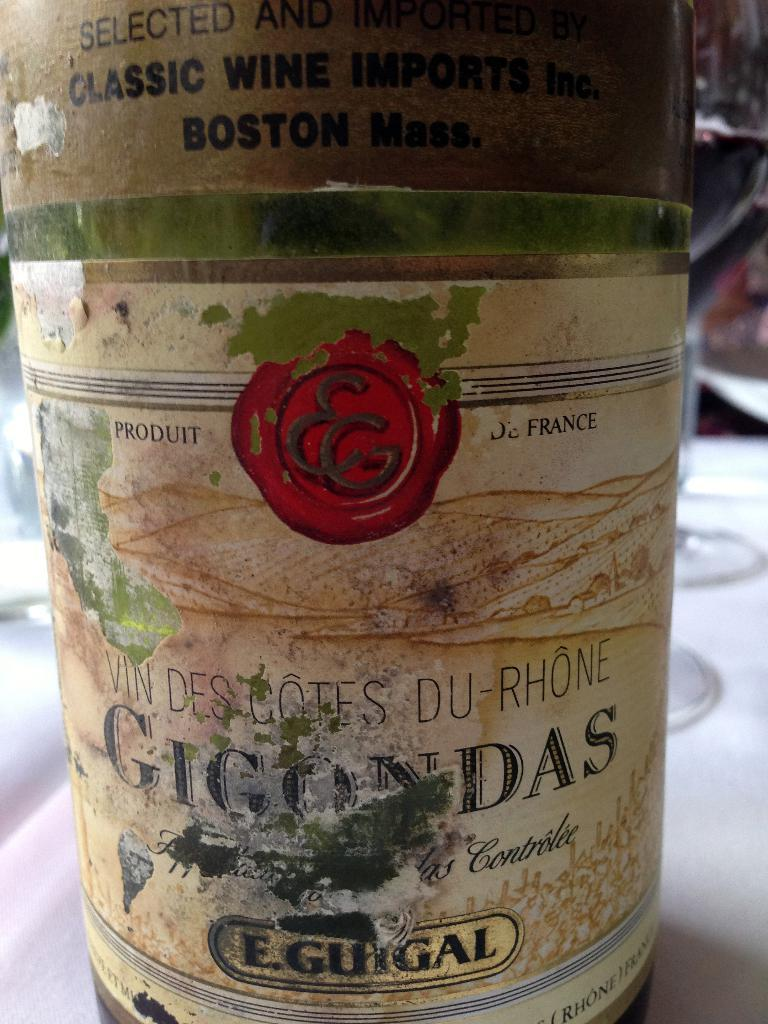<image>
Give a short and clear explanation of the subsequent image. Product of France wine container that says Selected and Imported Classic Wine Imports Inc. Boston Mass. 